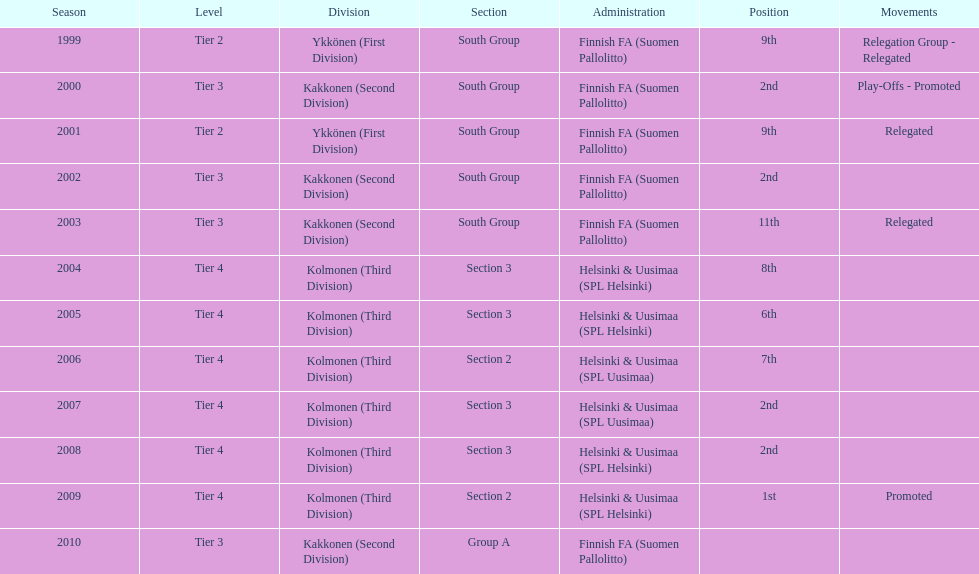What position did this team get after getting 9th place in 1999? 2nd. Give me the full table as a dictionary. {'header': ['Season', 'Level', 'Division', 'Section', 'Administration', 'Position', 'Movements'], 'rows': [['1999', 'Tier 2', 'Ykkönen (First Division)', 'South Group', 'Finnish FA (Suomen Pallolitto)', '9th', 'Relegation Group - Relegated'], ['2000', 'Tier 3', 'Kakkonen (Second Division)', 'South Group', 'Finnish FA (Suomen Pallolitto)', '2nd', 'Play-Offs - Promoted'], ['2001', 'Tier 2', 'Ykkönen (First Division)', 'South Group', 'Finnish FA (Suomen Pallolitto)', '9th', 'Relegated'], ['2002', 'Tier 3', 'Kakkonen (Second Division)', 'South Group', 'Finnish FA (Suomen Pallolitto)', '2nd', ''], ['2003', 'Tier 3', 'Kakkonen (Second Division)', 'South Group', 'Finnish FA (Suomen Pallolitto)', '11th', 'Relegated'], ['2004', 'Tier 4', 'Kolmonen (Third Division)', 'Section 3', 'Helsinki & Uusimaa (SPL Helsinki)', '8th', ''], ['2005', 'Tier 4', 'Kolmonen (Third Division)', 'Section 3', 'Helsinki & Uusimaa (SPL Helsinki)', '6th', ''], ['2006', 'Tier 4', 'Kolmonen (Third Division)', 'Section 2', 'Helsinki & Uusimaa (SPL Uusimaa)', '7th', ''], ['2007', 'Tier 4', 'Kolmonen (Third Division)', 'Section 3', 'Helsinki & Uusimaa (SPL Uusimaa)', '2nd', ''], ['2008', 'Tier 4', 'Kolmonen (Third Division)', 'Section 3', 'Helsinki & Uusimaa (SPL Helsinki)', '2nd', ''], ['2009', 'Tier 4', 'Kolmonen (Third Division)', 'Section 2', 'Helsinki & Uusimaa (SPL Helsinki)', '1st', 'Promoted'], ['2010', 'Tier 3', 'Kakkonen (Second Division)', 'Group A', 'Finnish FA (Suomen Pallolitto)', '', '']]} 